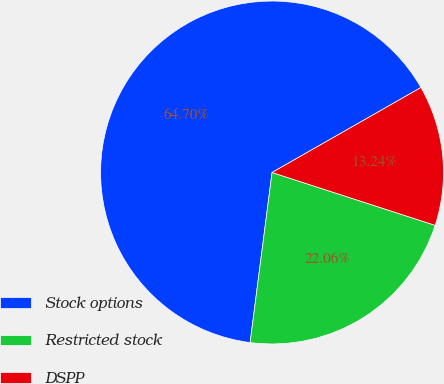<chart> <loc_0><loc_0><loc_500><loc_500><pie_chart><fcel>Stock options<fcel>Restricted stock<fcel>DSPP<nl><fcel>64.71%<fcel>22.06%<fcel>13.24%<nl></chart> 